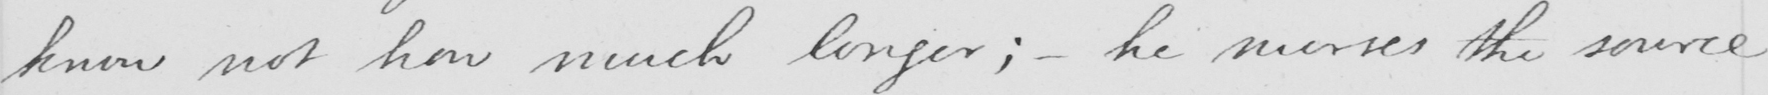Can you tell me what this handwritten text says? know not how much longer ;  _  he nurses the source 